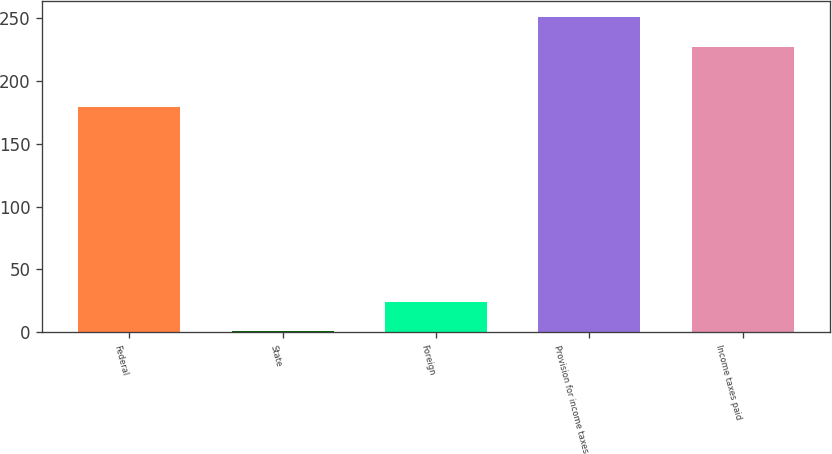Convert chart. <chart><loc_0><loc_0><loc_500><loc_500><bar_chart><fcel>Federal<fcel>State<fcel>Foreign<fcel>Provision for income taxes<fcel>Income taxes paid<nl><fcel>179.8<fcel>0.7<fcel>24.35<fcel>251.25<fcel>227.6<nl></chart> 